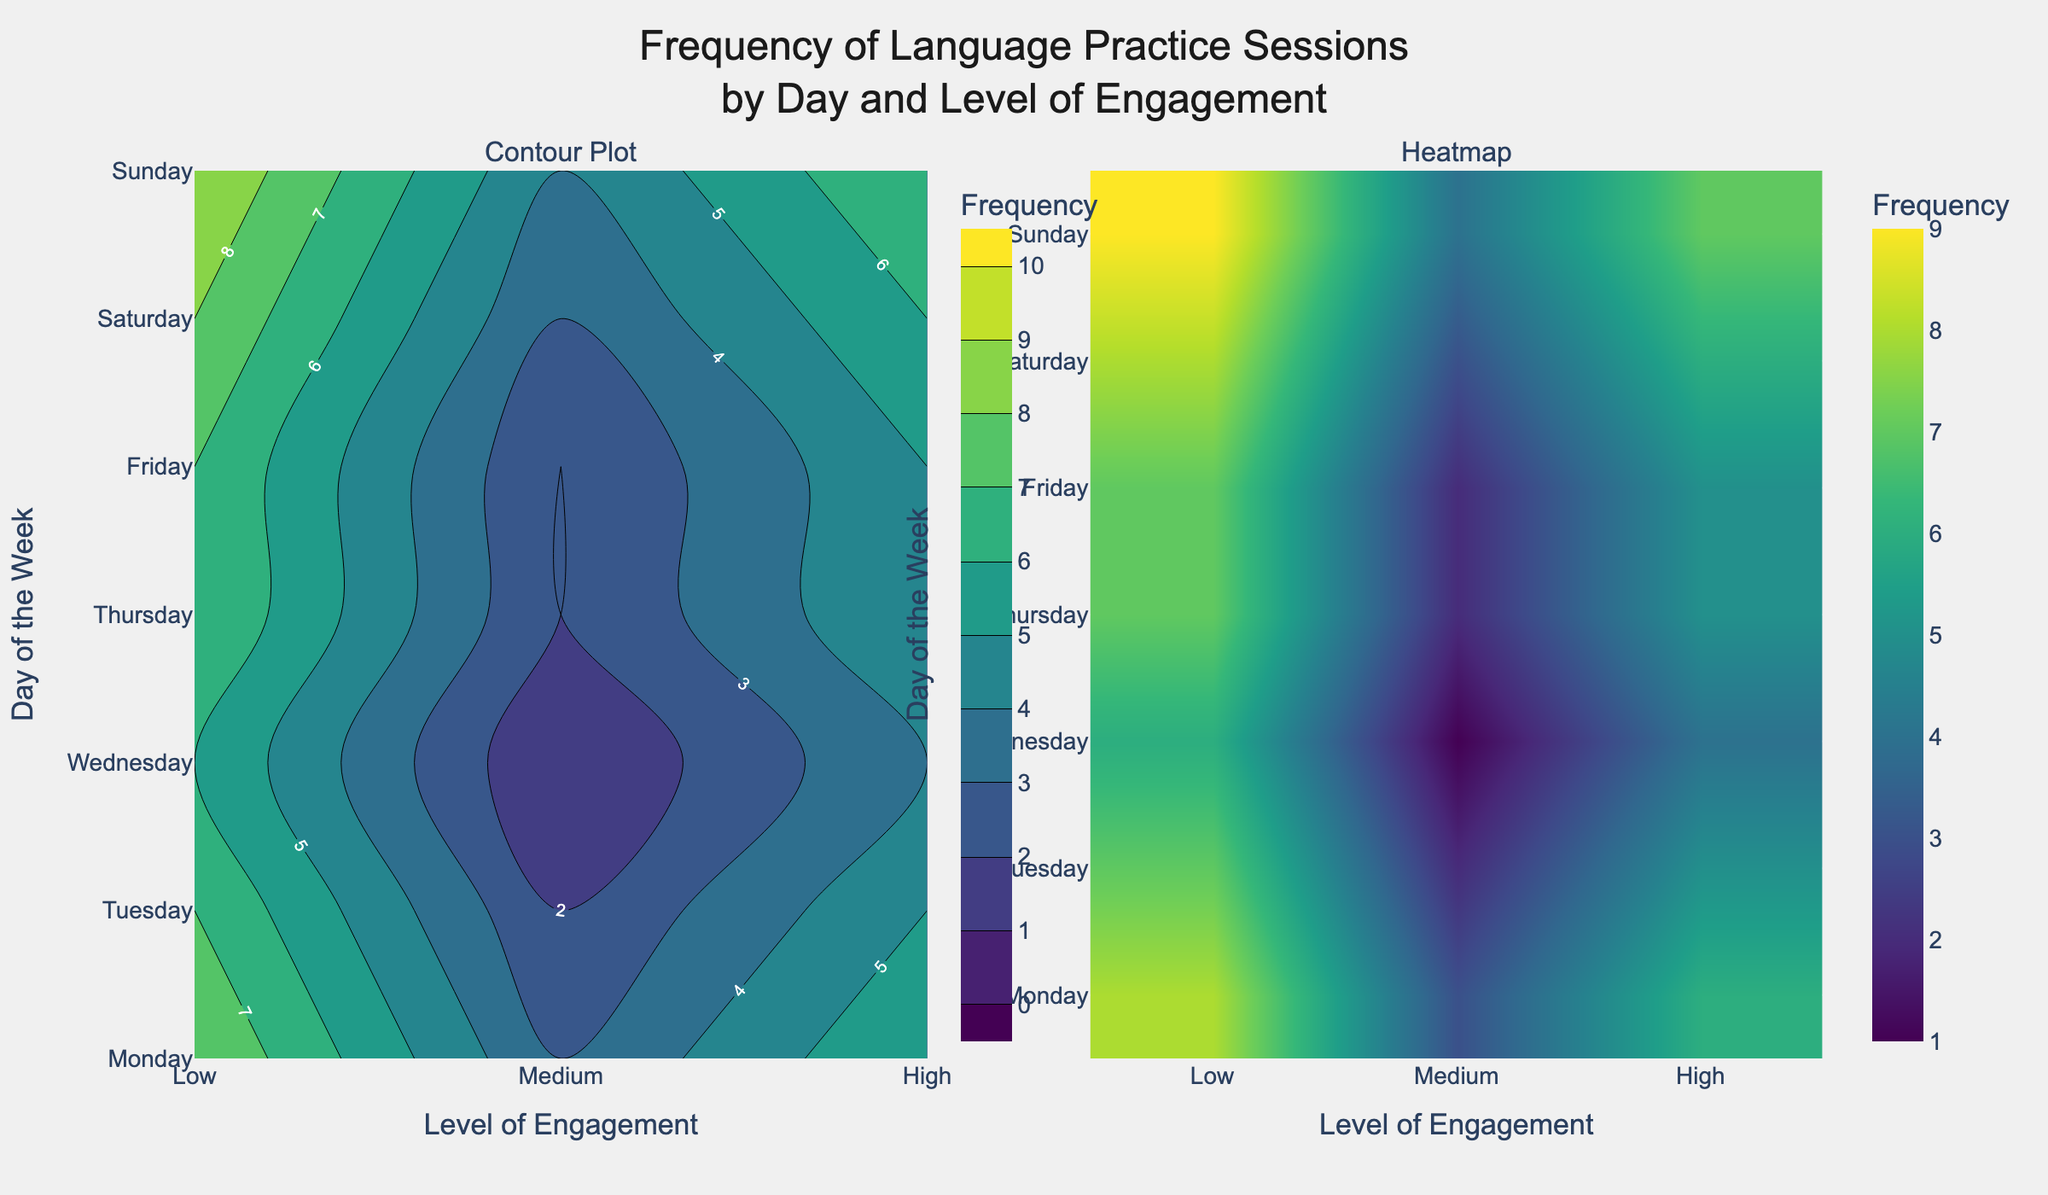What's the title of the figure? The title is typically placed at the top of the figure, and it summarizes what the figure is about. In this case, the title describes the frequency of language practice sessions by day of the week and level of engagement among German learners.
Answer: "Frequency of Language Practice Sessions by Day and Level of Engagement" What days are covered in the plot? The days are listed on the y-axis, which indicates the different days of the week included in the analysis. The days in the plot are Monday to Sunday.
Answer: Monday, Tuesday, Wednesday, Thursday, Friday, Saturday, Sunday What does the color bar represent in both subplots? The color bar, located next to each subplot, indicates the frequency of language practice sessions. The colors range from a light to darker shade, showing the variation in the frequency values.
Answer: Frequency What is the frequency of high engagement sessions on Wednesday? To find this, look at the heatmap or contour plot for Wednesday along the row where the 'High' engagement level intersects. The frequency value is given by the color intensity at this intersection.
Answer: 9 Does Saturday have the least number of high engagement sessions? Compare the frequency of high engagement sessions on Saturday with those on other days by looking at the 'High' row in both subplots. You'll notice the frequency is 6 on Saturday.
Answer: Yes Which day has the highest number of medium engagement sessions? Look at the contour or heatmap subplots and find the day with the highest value for 'Medium' engagement sessions. Identify the day by following the y-axis labels to the corresponding frequency.
Answer: Wednesday What is the average frequency of low engagement sessions throughout the week? Add the frequencies of low engagement sessions for each day (Monday: 2, Tuesday: 3, Wednesday: 4, Thursday: 2, Friday: 3, Saturday: 1, Sunday: 2) and then divide by the number of days (7). The calculation is (2+3+4+2+3+1+2)/7 = 2.43.
Answer: 2.43 Is the frequency of language practice sessions on Tuesday higher in all engagement levels compared to Monday? Compare the frequencies for each engagement level between Monday and Tuesday. Check 'Low', 'Medium', and 'High' rows for both days in the contour or heatmap plot to see which has higher frequencies.
Answer: Yes Which engagement level shows the highest variability in frequency across the week? Determine the variability by inspecting the range of frequencies across the week for each engagement level ("Low", "Medium", "High"). Calculate the difference between the maximum and minimum values for each level.
Answer: High How does the distribution of practice sessions differ between Monday and Friday for medium engagement? Compare the frequency values of 'Medium' engagement for Monday and Friday. Look at the specific intersection points on Monday and Friday for the medium level and note the frequency values.
Answer: Monday: 5, Friday: 6 